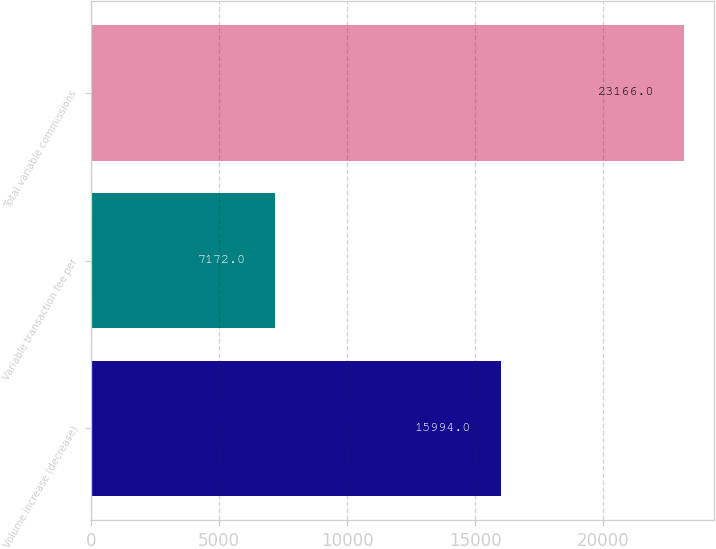<chart> <loc_0><loc_0><loc_500><loc_500><bar_chart><fcel>Volume increase (decrease)<fcel>Variable transaction fee per<fcel>Total variable commissions<nl><fcel>15994<fcel>7172<fcel>23166<nl></chart> 